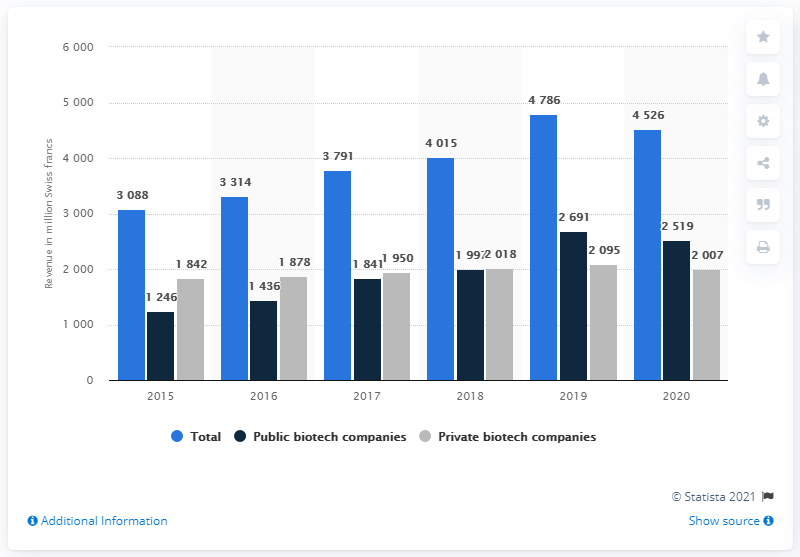Mention a couple of crucial points in this snapshot. In 2020, the amount of Swiss francs received from private companies was 4,526. The total revenues of all Swiss biotech companies in 2020 were approximately 4,526. 